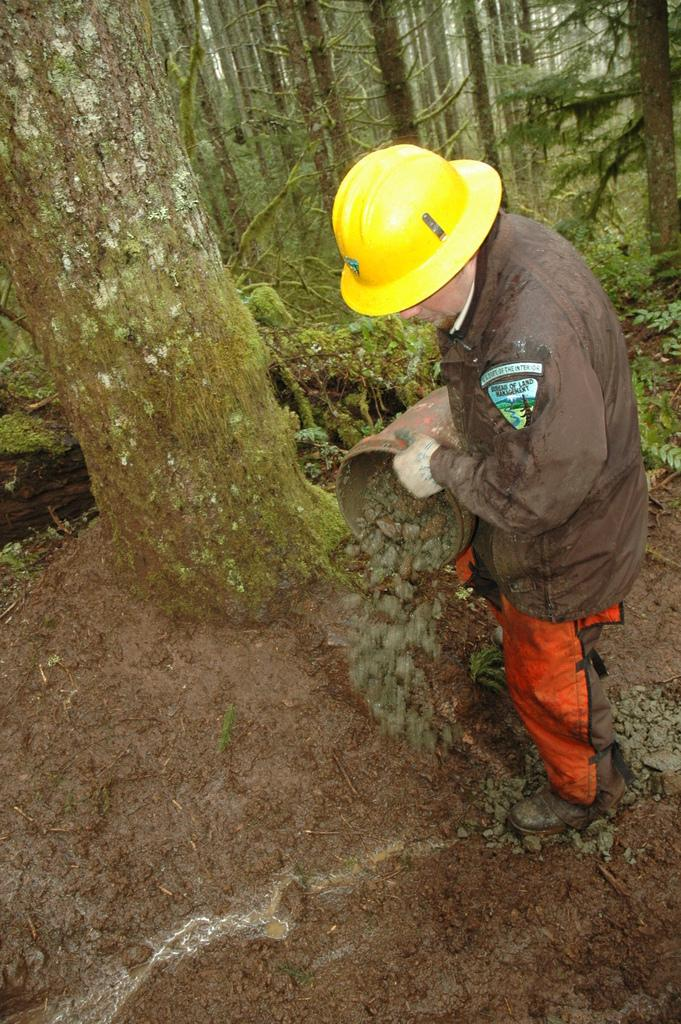What is the person in the image doing? The person is standing in the image and holding a bucket. What is inside the bucket? There are objects resembling rocks in the bucket. What can be seen in the background of the image? There are trees in the background of the image. What type of record can be seen on the person's knee in the image? There is no record visible on the person's knee in the image. What street is the person standing on in the image? The image does not show a street, so it cannot be determined where the person is standing. 